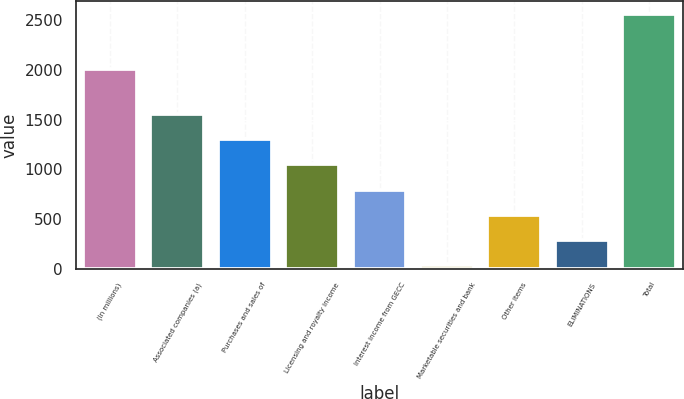Convert chart to OTSL. <chart><loc_0><loc_0><loc_500><loc_500><bar_chart><fcel>(In millions)<fcel>Associated companies (a)<fcel>Purchases and sales of<fcel>Licensing and royalty income<fcel>Interest income from GECC<fcel>Marketable securities and bank<fcel>Other items<fcel>ELIMINATIONS<fcel>Total<nl><fcel>2012<fcel>1553<fcel>1300.5<fcel>1048<fcel>795.5<fcel>38<fcel>543<fcel>290.5<fcel>2563<nl></chart> 